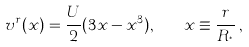Convert formula to latex. <formula><loc_0><loc_0><loc_500><loc_500>v ^ { r } ( x ) = \frac { U } { 2 } ( 3 x - x ^ { 3 } ) , \quad x \equiv \frac { r } { R _ { ^ { * } } } \, ,</formula> 